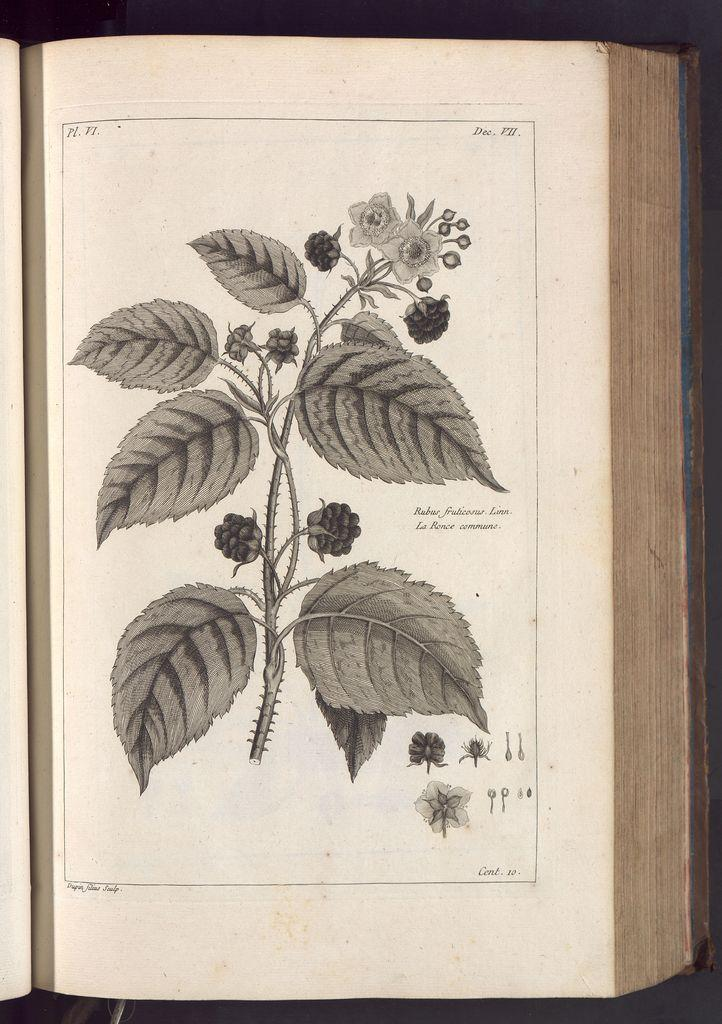What is the main object in the image? There is an open book in the image. What type of natural elements can be seen in the image? Leaves, flowers, and stems are visible in the image. What can be read or seen on the open book? There is text visible on the open book. Are there any additional objects or elements on the open book? Yes, there are additional objects or elements on the open book. How does the pot contribute to the image? There is no pot present in the image. What type of bridge can be seen connecting the flowers in the image? There is no bridge present in the image; the flowers are not connected by a bridge. 